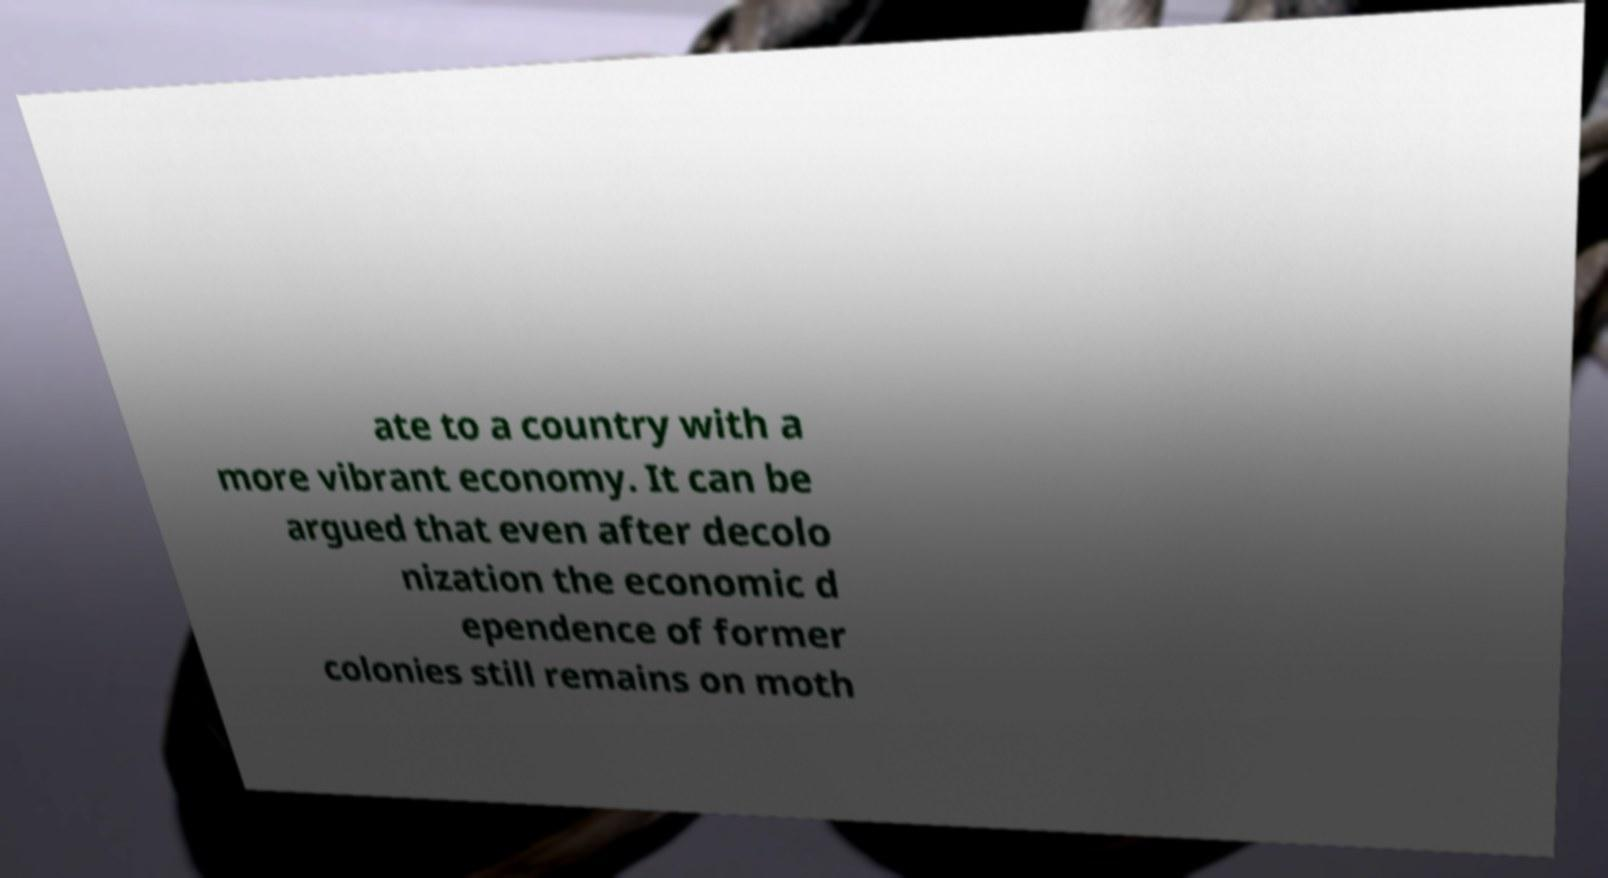Please read and relay the text visible in this image. What does it say? ate to a country with a more vibrant economy. It can be argued that even after decolo nization the economic d ependence of former colonies still remains on moth 